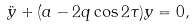Convert formula to latex. <formula><loc_0><loc_0><loc_500><loc_500>\ddot { y } + ( a - 2 q \cos 2 \tau ) y = 0 ,</formula> 